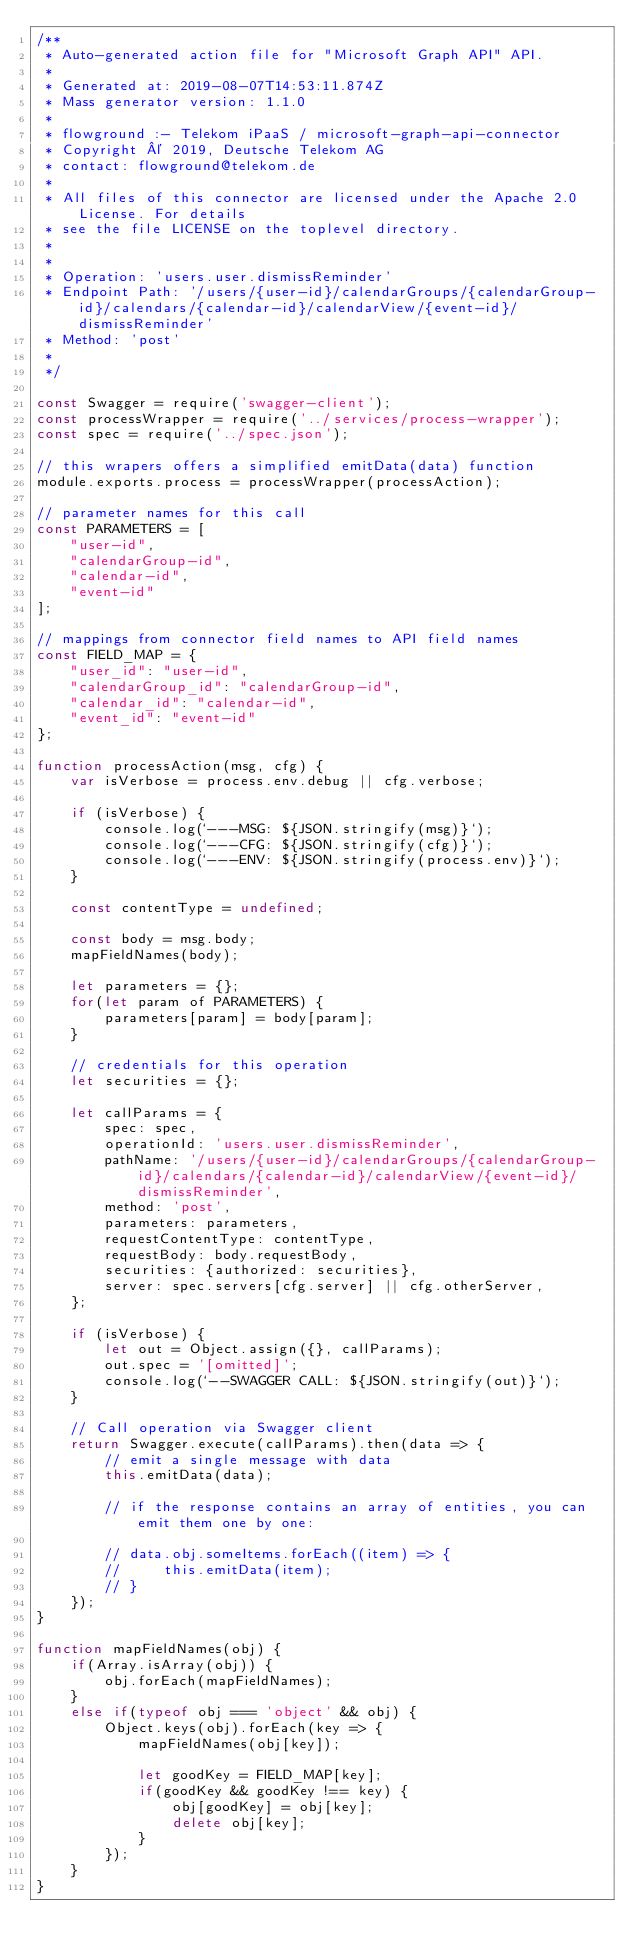Convert code to text. <code><loc_0><loc_0><loc_500><loc_500><_JavaScript_>/**
 * Auto-generated action file for "Microsoft Graph API" API.
 *
 * Generated at: 2019-08-07T14:53:11.874Z
 * Mass generator version: 1.1.0
 *
 * flowground :- Telekom iPaaS / microsoft-graph-api-connector
 * Copyright © 2019, Deutsche Telekom AG
 * contact: flowground@telekom.de
 *
 * All files of this connector are licensed under the Apache 2.0 License. For details
 * see the file LICENSE on the toplevel directory.
 *
 *
 * Operation: 'users.user.dismissReminder'
 * Endpoint Path: '/users/{user-id}/calendarGroups/{calendarGroup-id}/calendars/{calendar-id}/calendarView/{event-id}/dismissReminder'
 * Method: 'post'
 *
 */

const Swagger = require('swagger-client');
const processWrapper = require('../services/process-wrapper');
const spec = require('../spec.json');

// this wrapers offers a simplified emitData(data) function
module.exports.process = processWrapper(processAction);

// parameter names for this call
const PARAMETERS = [
    "user-id",
    "calendarGroup-id",
    "calendar-id",
    "event-id"
];

// mappings from connector field names to API field names
const FIELD_MAP = {
    "user_id": "user-id",
    "calendarGroup_id": "calendarGroup-id",
    "calendar_id": "calendar-id",
    "event_id": "event-id"
};

function processAction(msg, cfg) {
    var isVerbose = process.env.debug || cfg.verbose;

    if (isVerbose) {
        console.log(`---MSG: ${JSON.stringify(msg)}`);
        console.log(`---CFG: ${JSON.stringify(cfg)}`);
        console.log(`---ENV: ${JSON.stringify(process.env)}`);
    }

    const contentType = undefined;

    const body = msg.body;
    mapFieldNames(body);

    let parameters = {};
    for(let param of PARAMETERS) {
        parameters[param] = body[param];
    }

    // credentials for this operation
    let securities = {};

    let callParams = {
        spec: spec,
        operationId: 'users.user.dismissReminder',
        pathName: '/users/{user-id}/calendarGroups/{calendarGroup-id}/calendars/{calendar-id}/calendarView/{event-id}/dismissReminder',
        method: 'post',
        parameters: parameters,
        requestContentType: contentType,
        requestBody: body.requestBody,
        securities: {authorized: securities},
        server: spec.servers[cfg.server] || cfg.otherServer,
    };

    if (isVerbose) {
        let out = Object.assign({}, callParams);
        out.spec = '[omitted]';
        console.log(`--SWAGGER CALL: ${JSON.stringify(out)}`);
    }

    // Call operation via Swagger client
    return Swagger.execute(callParams).then(data => {
        // emit a single message with data
        this.emitData(data);

        // if the response contains an array of entities, you can emit them one by one:

        // data.obj.someItems.forEach((item) => {
        //     this.emitData(item);
        // }
    });
}

function mapFieldNames(obj) {
    if(Array.isArray(obj)) {
        obj.forEach(mapFieldNames);
    }
    else if(typeof obj === 'object' && obj) {
        Object.keys(obj).forEach(key => {
            mapFieldNames(obj[key]);

            let goodKey = FIELD_MAP[key];
            if(goodKey && goodKey !== key) {
                obj[goodKey] = obj[key];
                delete obj[key];
            }
        });
    }
}</code> 